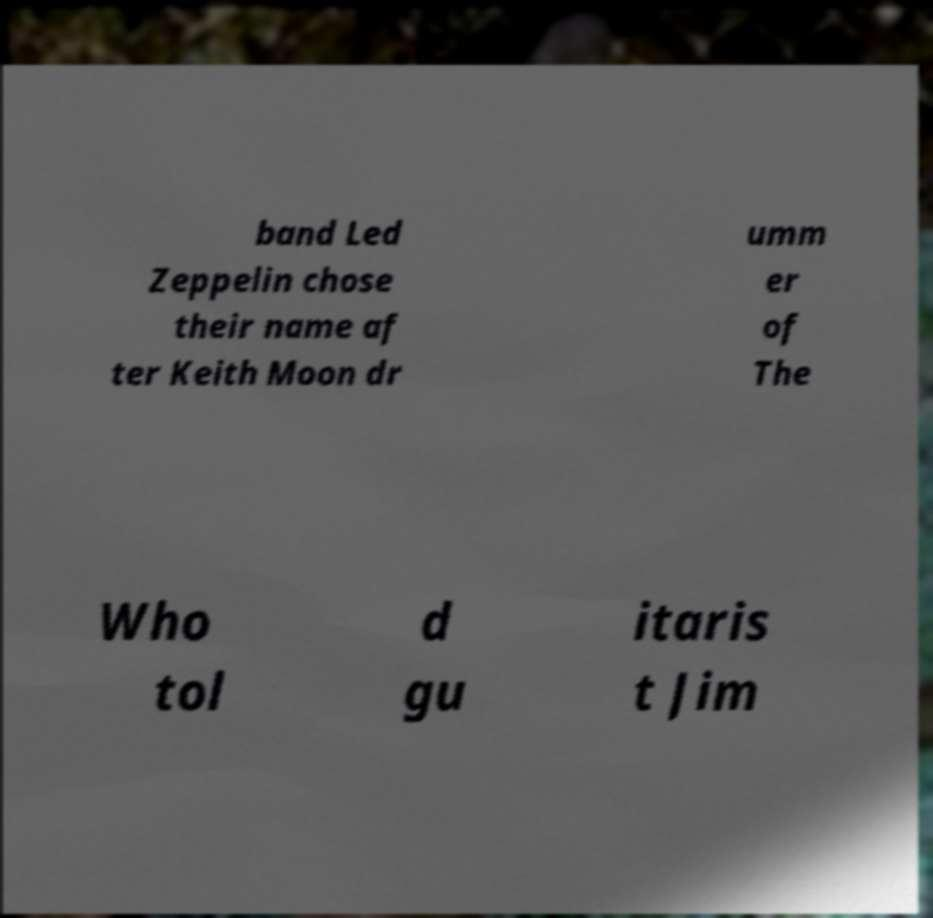For documentation purposes, I need the text within this image transcribed. Could you provide that? band Led Zeppelin chose their name af ter Keith Moon dr umm er of The Who tol d gu itaris t Jim 